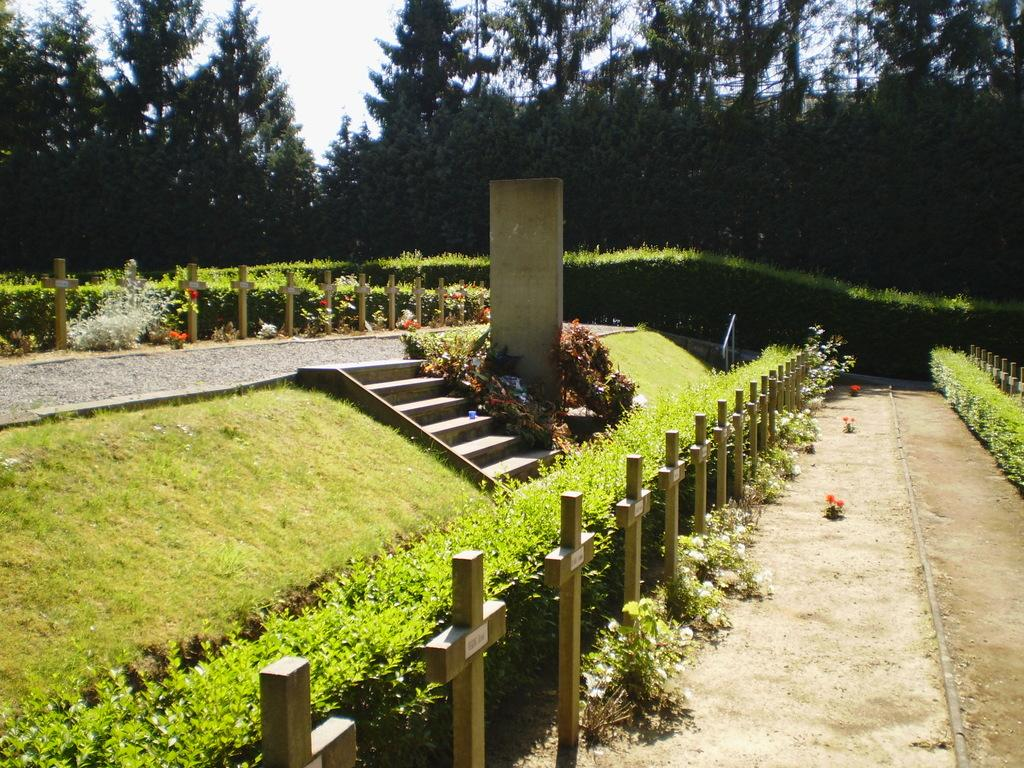What type of structure is present in the image? There are stairs in the image. What is located near the stairs? There is a plant beside the stairs. What type of vegetation can be seen in the image? There is grass in the image. What is visible at the top of the image? The sky is visible at the top of the image. What can be observed in the sky? Clouds are present in the sky. What type of music is being played by the son in the image? There is no son or music present in the image; it only features stairs, a plant, grass, sky, and clouds. 